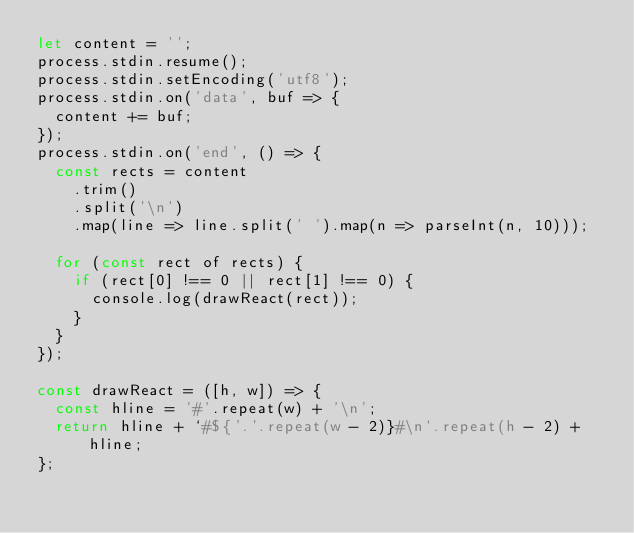Convert code to text. <code><loc_0><loc_0><loc_500><loc_500><_JavaScript_>let content = '';
process.stdin.resume();
process.stdin.setEncoding('utf8');
process.stdin.on('data', buf => {
  content += buf;
});
process.stdin.on('end', () => {
  const rects = content
    .trim()
    .split('\n')
    .map(line => line.split(' ').map(n => parseInt(n, 10)));

  for (const rect of rects) {
    if (rect[0] !== 0 || rect[1] !== 0) {
      console.log(drawReact(rect));
    }
  }
});

const drawReact = ([h, w]) => {
  const hline = '#'.repeat(w) + '\n';
  return hline + `#${'.'.repeat(w - 2)}#\n`.repeat(h - 2) + hline;
};
</code> 